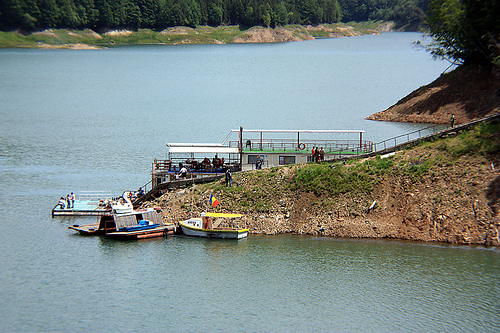<image>Which boat is motorized? It is ambiguous as to which boat is motorized. It could possibly be the boat with the yellow top, the right one or none of them. Which boat is motorized? I don't know which boat is motorized. It can be any of them. 